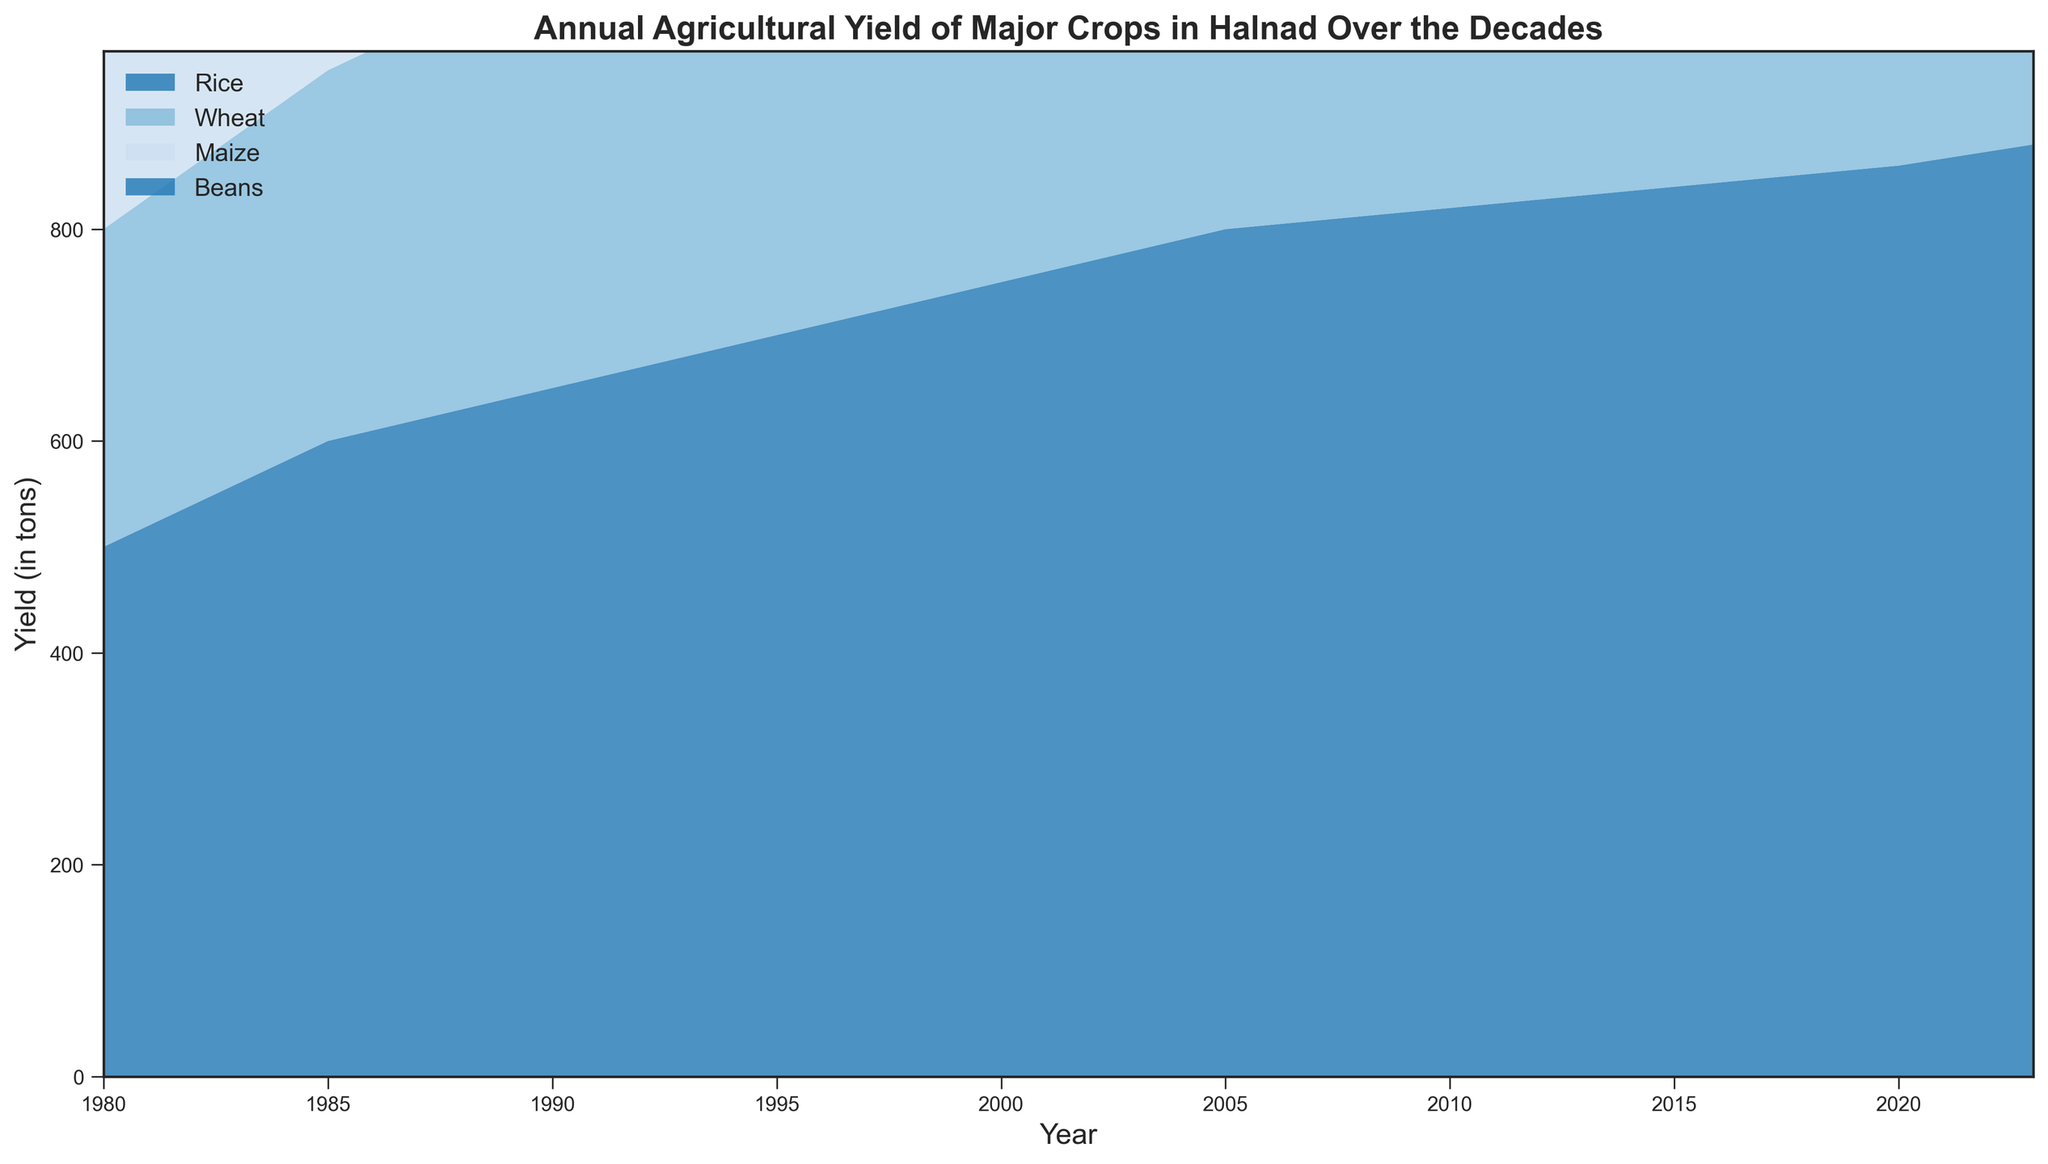What was the total yield of all crops in the year 2000? In the year 2000, sum the yields of Rice, Wheat, Maize, and Beans: 750 + 500 + 320 + 200.
Answer: 1770 tons Which crop showed the highest yield increase between 1980 and 2023? Calculate the difference for each crop between 1980 and 2023: Rice (880 - 500 = 380), Wheat (650 - 300 = 350), Maize (420 - 200 = 220), Beans (300 - 100 = 200). Rice had the highest increase.
Answer: Rice In which year did Wheat surpass 500 tons in yield? By checking the Wheat values, Wheat yield surpassed 500 tons first in the year 2000.
Answer: 2000 How much did the yield of Maize increase on average per decade from 1980 to 2020? Calculate the total increase from 1980 to 2020 (400 - 200 = 200), then divide by 4 decades: 200/4 = 50.
Answer: 50 tons per decade Compare the yields of Rice and Beans in 2010. How much greater or lesser was the yield of Rice? In 2010, Rice yield was 820 tons and Beans yield was 240 tons. Subtract the yield of Beans from Rice: 820 - 240.
Answer: 580 tons greater Which crop consistently yielded more than 300 tons from 1985 onwards? From 1985 onwards, by inspecting the data, Rice always yielded more than 300 tons.
Answer: Rice What is the visual trend for the yield of Beans over the decades? Visually, the yield of Beans consistently increases over the years from 1980 to 2023.
Answer: Increasing trend In which decade did the sum of Wheat and Maize yields first exceed 600 tons? Calculate the sum of Wheat and Maize each decade. First exceed 600 tons in 2000: Wheat (500) + Maize (320) = 820.
Answer: 2000 Between Rice and Wheat, which crop had a relatively steadier increase in yield over the indicated period? Comparing the year-by-year increases, Wheat's yield changes are more consistent without sudden large jumps compared to Rice.
Answer: Wheat 